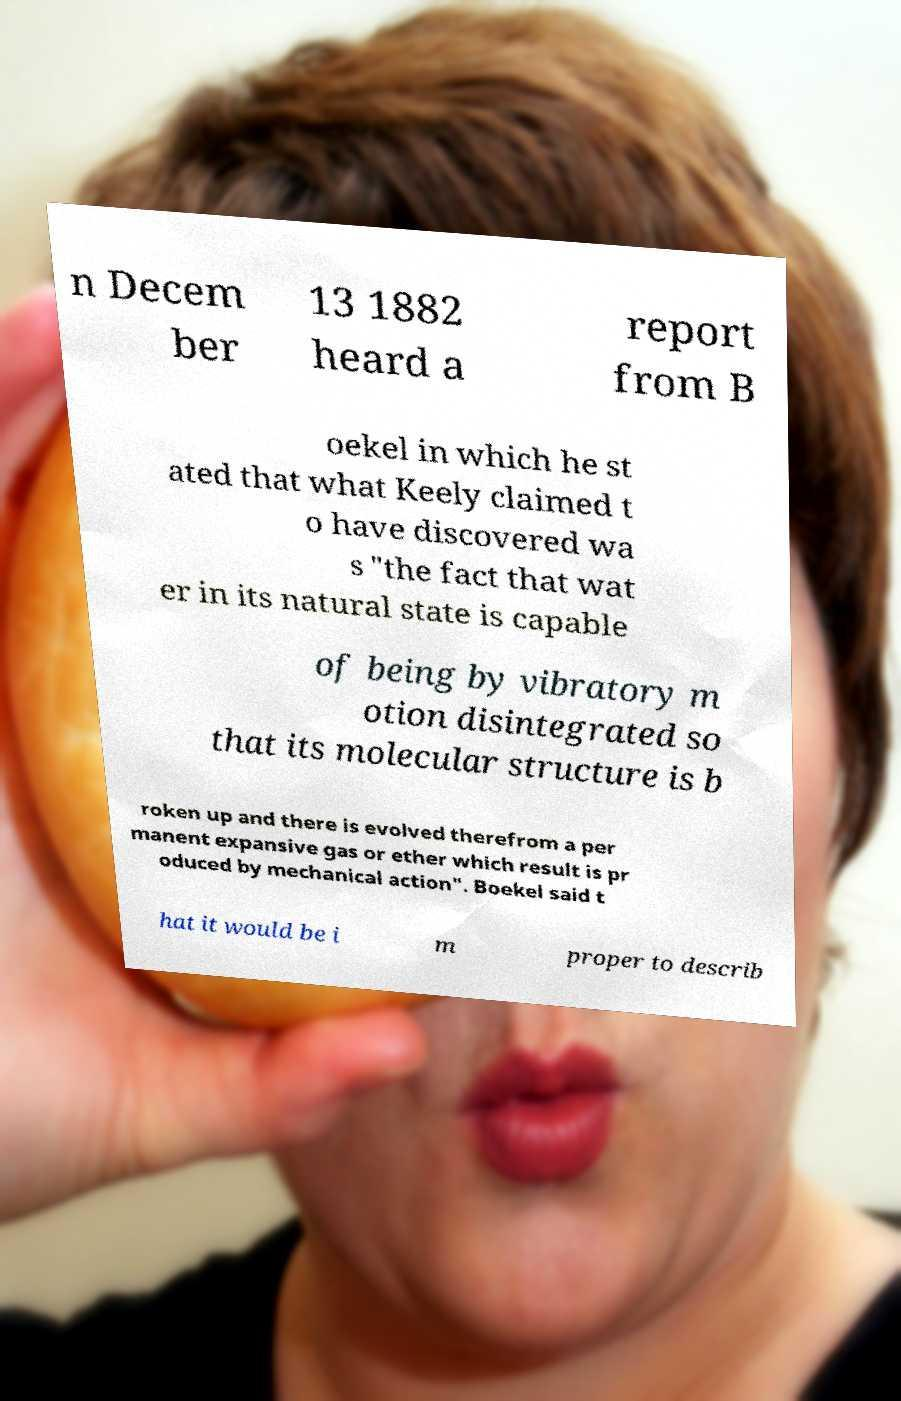Can you read and provide the text displayed in the image?This photo seems to have some interesting text. Can you extract and type it out for me? n Decem ber 13 1882 heard a report from B oekel in which he st ated that what Keely claimed t o have discovered wa s "the fact that wat er in its natural state is capable of being by vibratory m otion disintegrated so that its molecular structure is b roken up and there is evolved therefrom a per manent expansive gas or ether which result is pr oduced by mechanical action". Boekel said t hat it would be i m proper to describ 